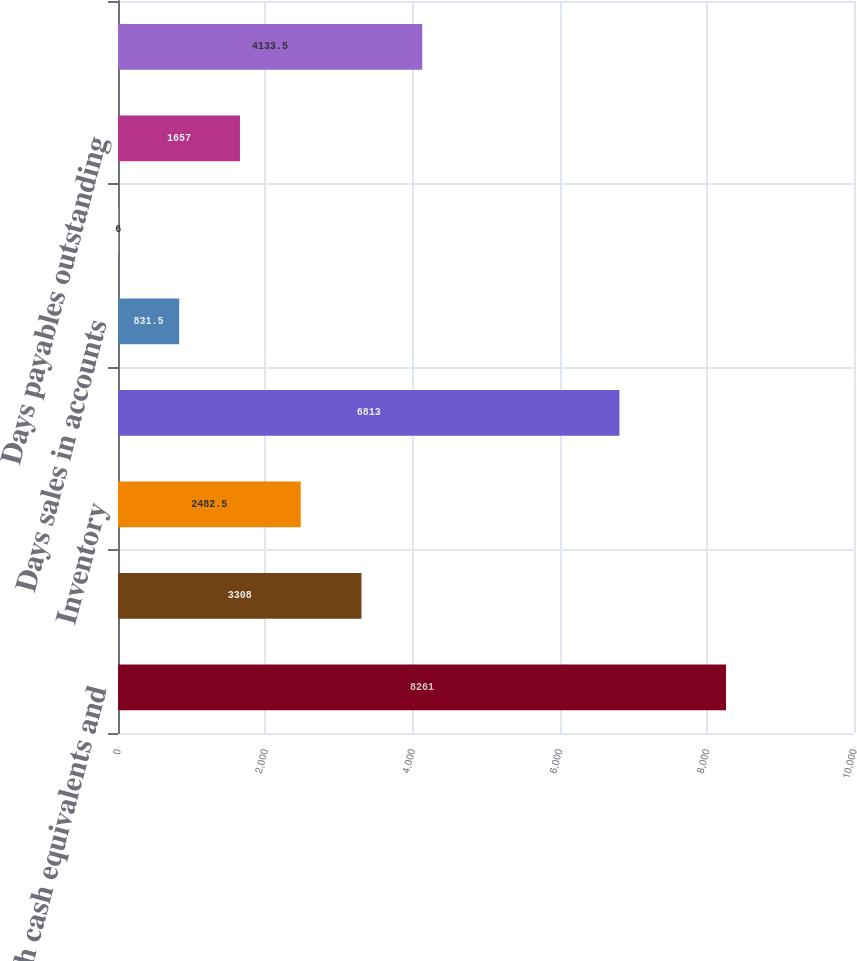Convert chart. <chart><loc_0><loc_0><loc_500><loc_500><bar_chart><fcel>Cash cash equivalents and<fcel>Accounts receivable net<fcel>Inventory<fcel>Working capital<fcel>Days sales in accounts<fcel>Days of supply in inventory<fcel>Days payables outstanding<fcel>Annual operating cash flow<nl><fcel>8261<fcel>3308<fcel>2482.5<fcel>6813<fcel>831.5<fcel>6<fcel>1657<fcel>4133.5<nl></chart> 